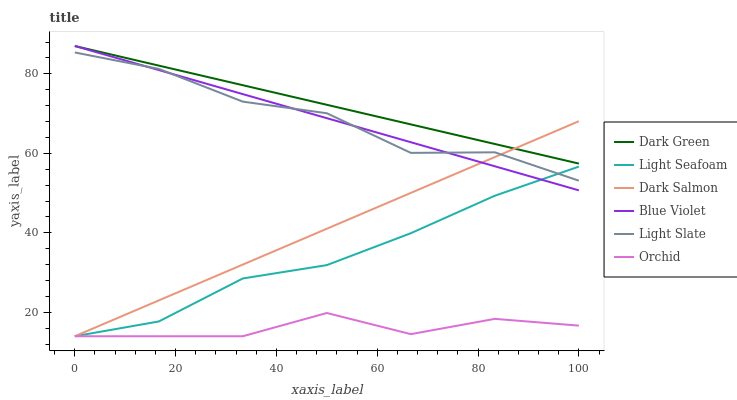Does Orchid have the minimum area under the curve?
Answer yes or no. Yes. Does Dark Green have the maximum area under the curve?
Answer yes or no. Yes. Does Dark Salmon have the minimum area under the curve?
Answer yes or no. No. Does Dark Salmon have the maximum area under the curve?
Answer yes or no. No. Is Dark Salmon the smoothest?
Answer yes or no. Yes. Is Light Slate the roughest?
Answer yes or no. Yes. Is Light Seafoam the smoothest?
Answer yes or no. No. Is Light Seafoam the roughest?
Answer yes or no. No. Does Dark Salmon have the lowest value?
Answer yes or no. Yes. Does Dark Green have the lowest value?
Answer yes or no. No. Does Blue Violet have the highest value?
Answer yes or no. Yes. Does Dark Salmon have the highest value?
Answer yes or no. No. Is Orchid less than Dark Green?
Answer yes or no. Yes. Is Blue Violet greater than Orchid?
Answer yes or no. Yes. Does Dark Salmon intersect Orchid?
Answer yes or no. Yes. Is Dark Salmon less than Orchid?
Answer yes or no. No. Is Dark Salmon greater than Orchid?
Answer yes or no. No. Does Orchid intersect Dark Green?
Answer yes or no. No. 